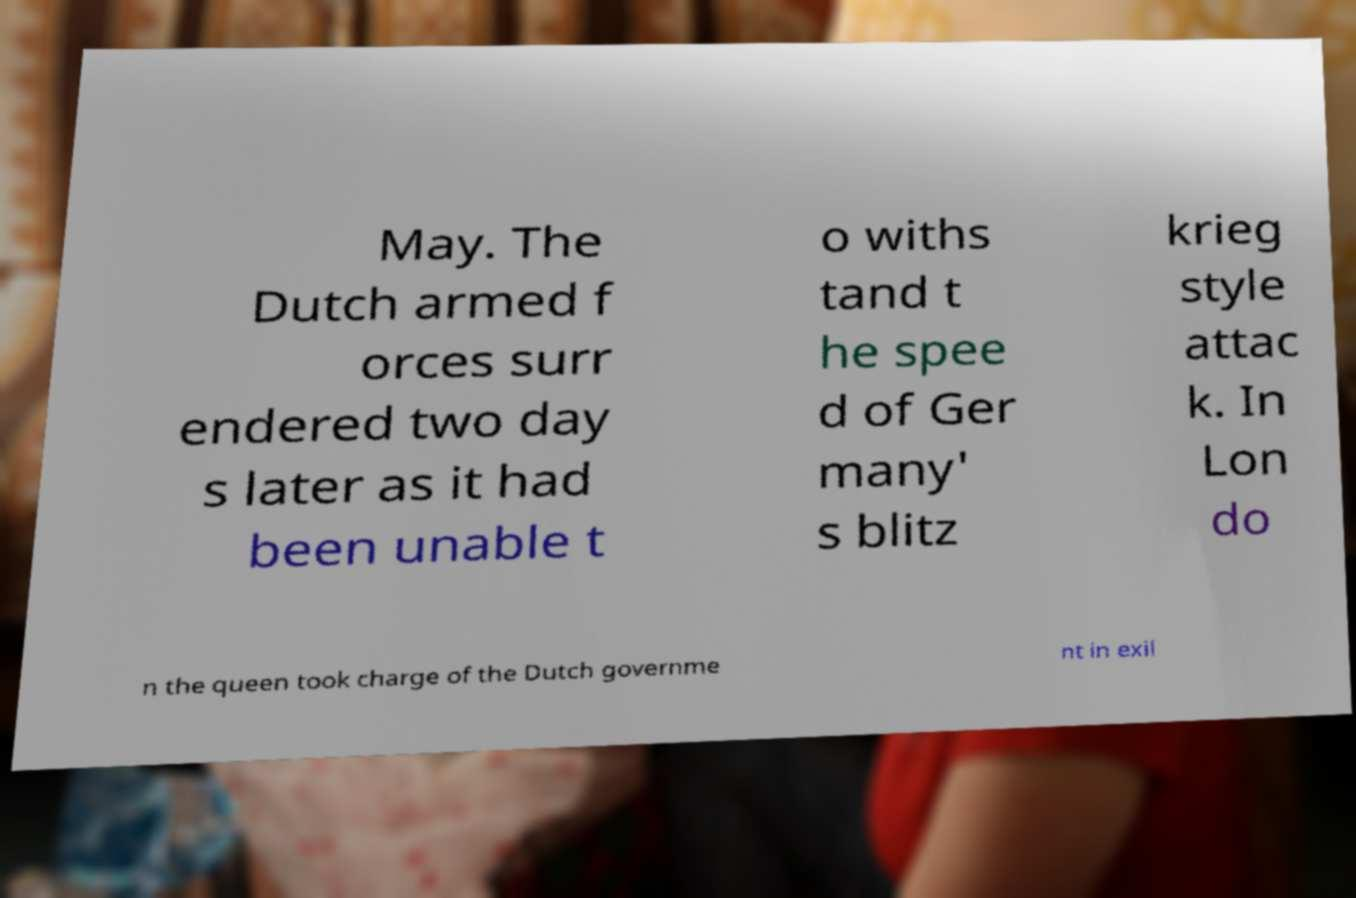Could you extract and type out the text from this image? May. The Dutch armed f orces surr endered two day s later as it had been unable t o withs tand t he spee d of Ger many' s blitz krieg style attac k. In Lon do n the queen took charge of the Dutch governme nt in exil 